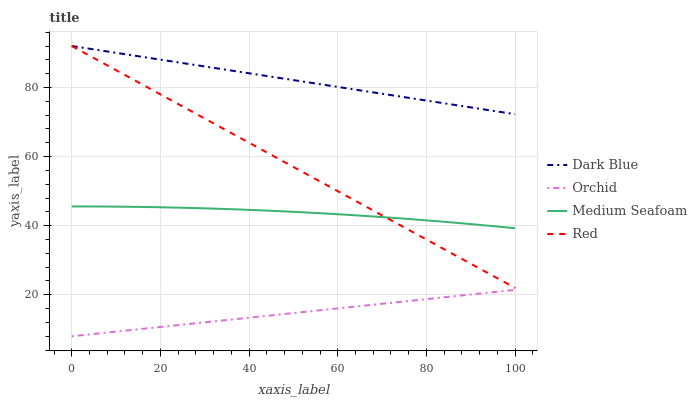Does Orchid have the minimum area under the curve?
Answer yes or no. Yes. Does Dark Blue have the maximum area under the curve?
Answer yes or no. Yes. Does Medium Seafoam have the minimum area under the curve?
Answer yes or no. No. Does Medium Seafoam have the maximum area under the curve?
Answer yes or no. No. Is Orchid the smoothest?
Answer yes or no. Yes. Is Medium Seafoam the roughest?
Answer yes or no. Yes. Is Red the smoothest?
Answer yes or no. No. Is Red the roughest?
Answer yes or no. No. Does Orchid have the lowest value?
Answer yes or no. Yes. Does Medium Seafoam have the lowest value?
Answer yes or no. No. Does Red have the highest value?
Answer yes or no. Yes. Does Medium Seafoam have the highest value?
Answer yes or no. No. Is Medium Seafoam less than Dark Blue?
Answer yes or no. Yes. Is Red greater than Orchid?
Answer yes or no. Yes. Does Medium Seafoam intersect Red?
Answer yes or no. Yes. Is Medium Seafoam less than Red?
Answer yes or no. No. Is Medium Seafoam greater than Red?
Answer yes or no. No. Does Medium Seafoam intersect Dark Blue?
Answer yes or no. No. 